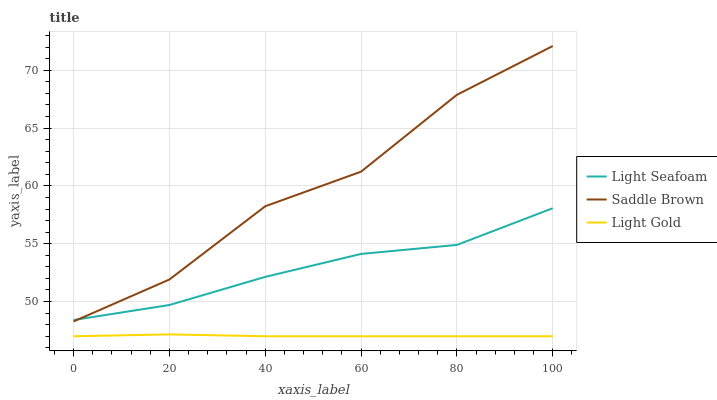Does Light Gold have the minimum area under the curve?
Answer yes or no. Yes. Does Saddle Brown have the maximum area under the curve?
Answer yes or no. Yes. Does Saddle Brown have the minimum area under the curve?
Answer yes or no. No. Does Light Gold have the maximum area under the curve?
Answer yes or no. No. Is Light Gold the smoothest?
Answer yes or no. Yes. Is Saddle Brown the roughest?
Answer yes or no. Yes. Is Saddle Brown the smoothest?
Answer yes or no. No. Is Light Gold the roughest?
Answer yes or no. No. Does Light Gold have the lowest value?
Answer yes or no. Yes. Does Saddle Brown have the lowest value?
Answer yes or no. No. Does Saddle Brown have the highest value?
Answer yes or no. Yes. Does Light Gold have the highest value?
Answer yes or no. No. Is Light Gold less than Saddle Brown?
Answer yes or no. Yes. Is Light Seafoam greater than Light Gold?
Answer yes or no. Yes. Does Light Seafoam intersect Saddle Brown?
Answer yes or no. Yes. Is Light Seafoam less than Saddle Brown?
Answer yes or no. No. Is Light Seafoam greater than Saddle Brown?
Answer yes or no. No. Does Light Gold intersect Saddle Brown?
Answer yes or no. No. 